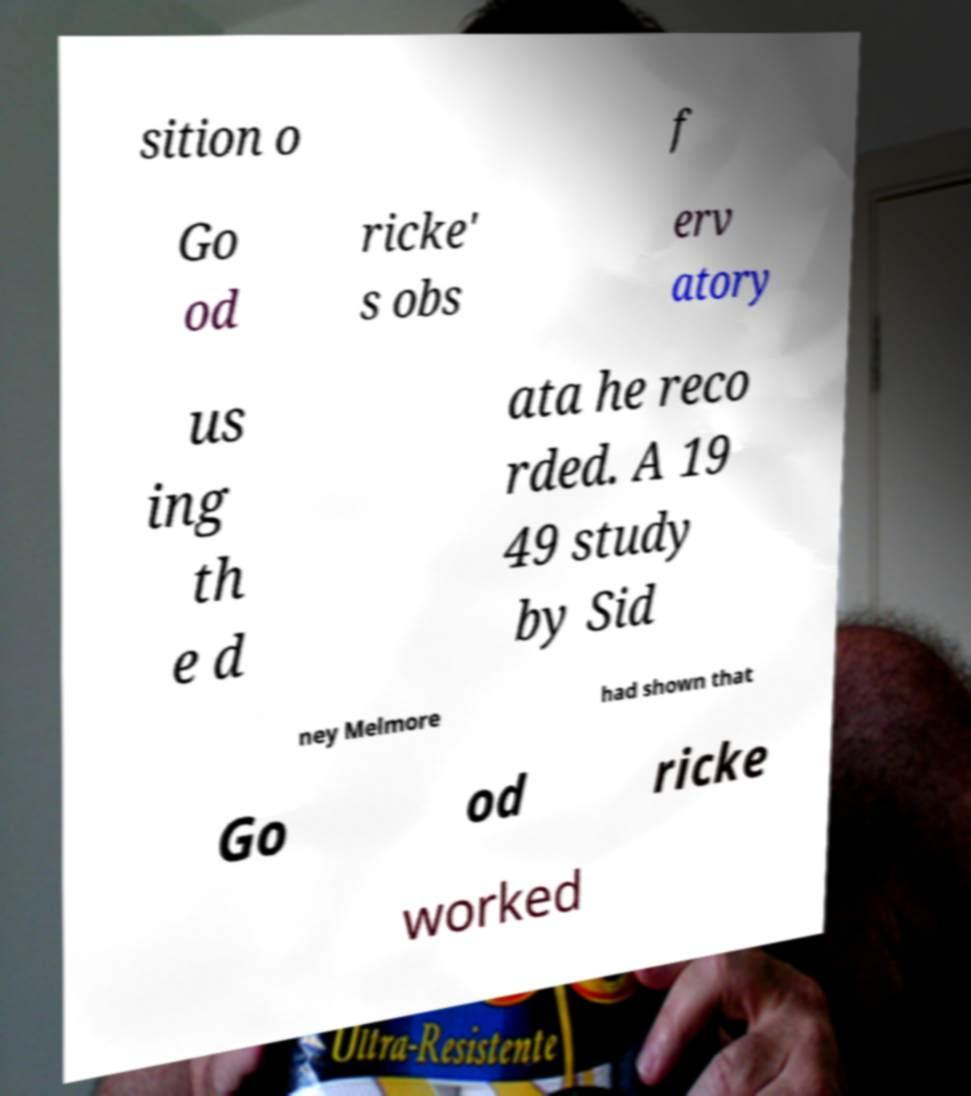There's text embedded in this image that I need extracted. Can you transcribe it verbatim? sition o f Go od ricke' s obs erv atory us ing th e d ata he reco rded. A 19 49 study by Sid ney Melmore had shown that Go od ricke worked 